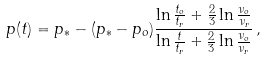Convert formula to latex. <formula><loc_0><loc_0><loc_500><loc_500>p ( t ) = p _ { * } - ( p _ { * } - p _ { o } ) \frac { \ln \frac { t _ { o } } { t _ { r } } + \frac { 2 } { 3 } \ln \frac { \nu _ { o } } { \nu _ { r } } } { \ln \frac { t } { t _ { r } } + \frac { 2 } { 3 } \ln \frac { \nu _ { o } } { \nu _ { r } } } \, ,</formula> 